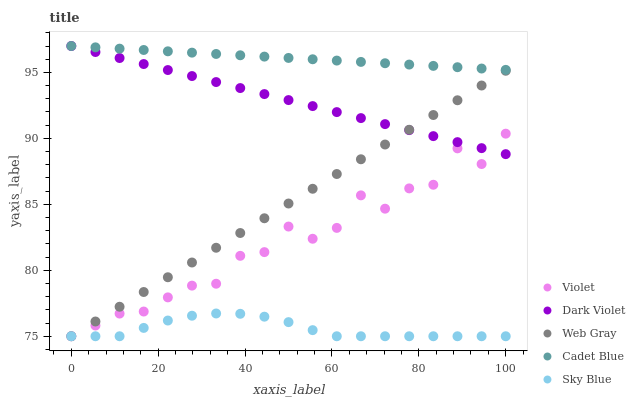Does Sky Blue have the minimum area under the curve?
Answer yes or no. Yes. Does Cadet Blue have the maximum area under the curve?
Answer yes or no. Yes. Does Web Gray have the minimum area under the curve?
Answer yes or no. No. Does Web Gray have the maximum area under the curve?
Answer yes or no. No. Is Web Gray the smoothest?
Answer yes or no. Yes. Is Violet the roughest?
Answer yes or no. Yes. Is Sky Blue the smoothest?
Answer yes or no. No. Is Sky Blue the roughest?
Answer yes or no. No. Does Sky Blue have the lowest value?
Answer yes or no. Yes. Does Dark Violet have the lowest value?
Answer yes or no. No. Does Dark Violet have the highest value?
Answer yes or no. Yes. Does Web Gray have the highest value?
Answer yes or no. No. Is Violet less than Cadet Blue?
Answer yes or no. Yes. Is Cadet Blue greater than Violet?
Answer yes or no. Yes. Does Dark Violet intersect Web Gray?
Answer yes or no. Yes. Is Dark Violet less than Web Gray?
Answer yes or no. No. Is Dark Violet greater than Web Gray?
Answer yes or no. No. Does Violet intersect Cadet Blue?
Answer yes or no. No. 